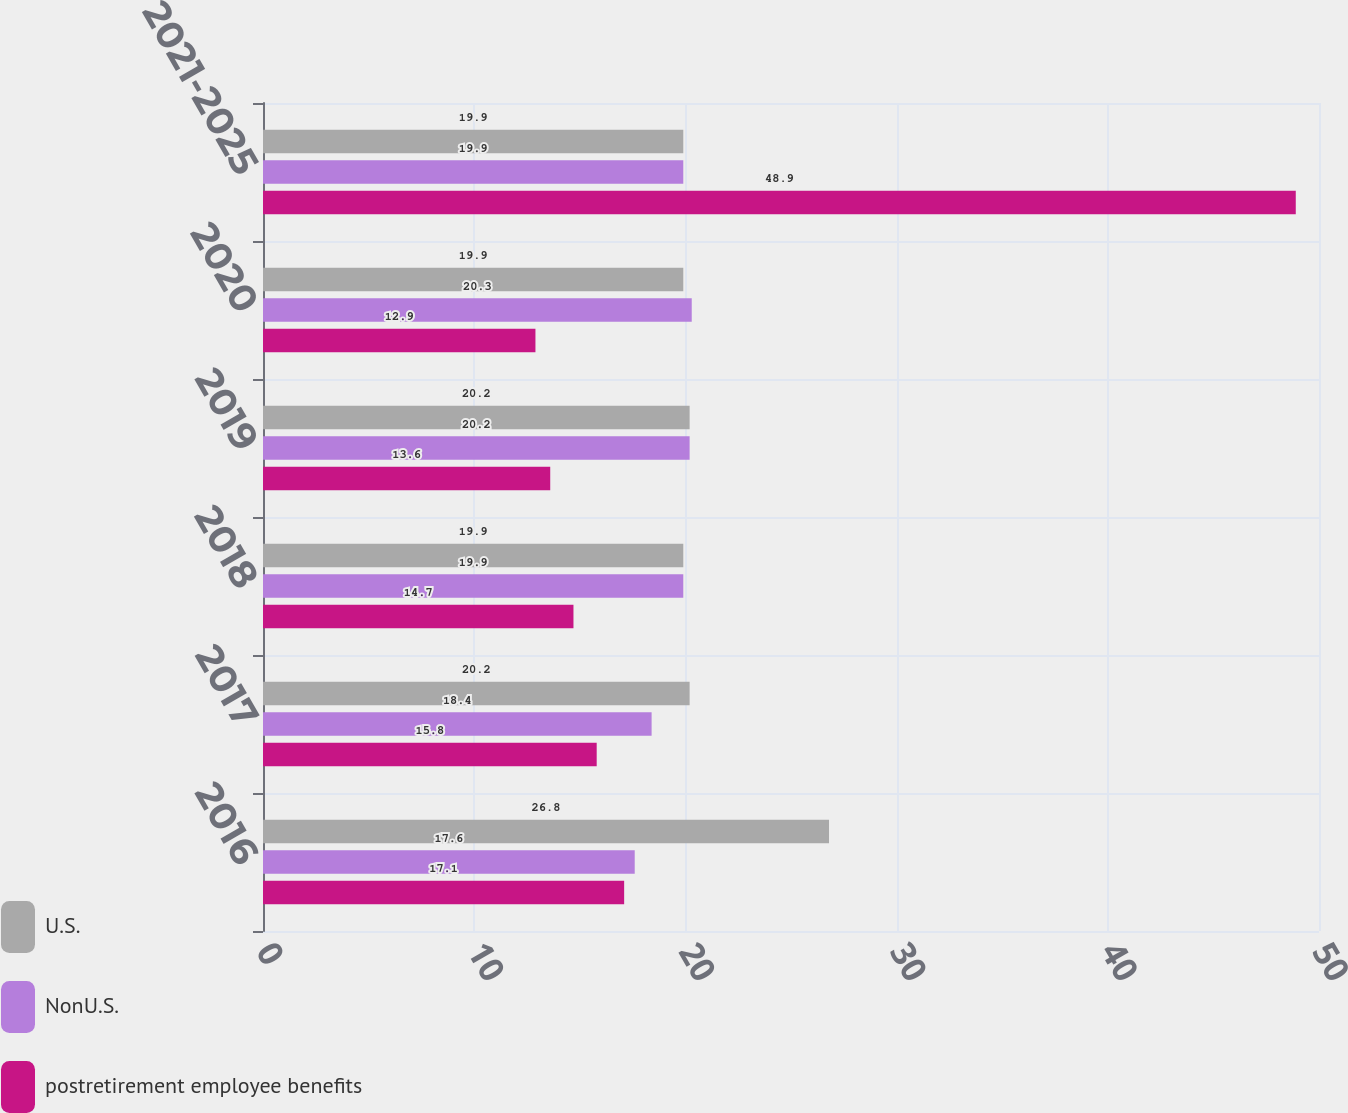<chart> <loc_0><loc_0><loc_500><loc_500><stacked_bar_chart><ecel><fcel>2016<fcel>2017<fcel>2018<fcel>2019<fcel>2020<fcel>2021-2025<nl><fcel>U.S.<fcel>26.8<fcel>20.2<fcel>19.9<fcel>20.2<fcel>19.9<fcel>19.9<nl><fcel>NonU.S.<fcel>17.6<fcel>18.4<fcel>19.9<fcel>20.2<fcel>20.3<fcel>19.9<nl><fcel>postretirement employee benefits<fcel>17.1<fcel>15.8<fcel>14.7<fcel>13.6<fcel>12.9<fcel>48.9<nl></chart> 